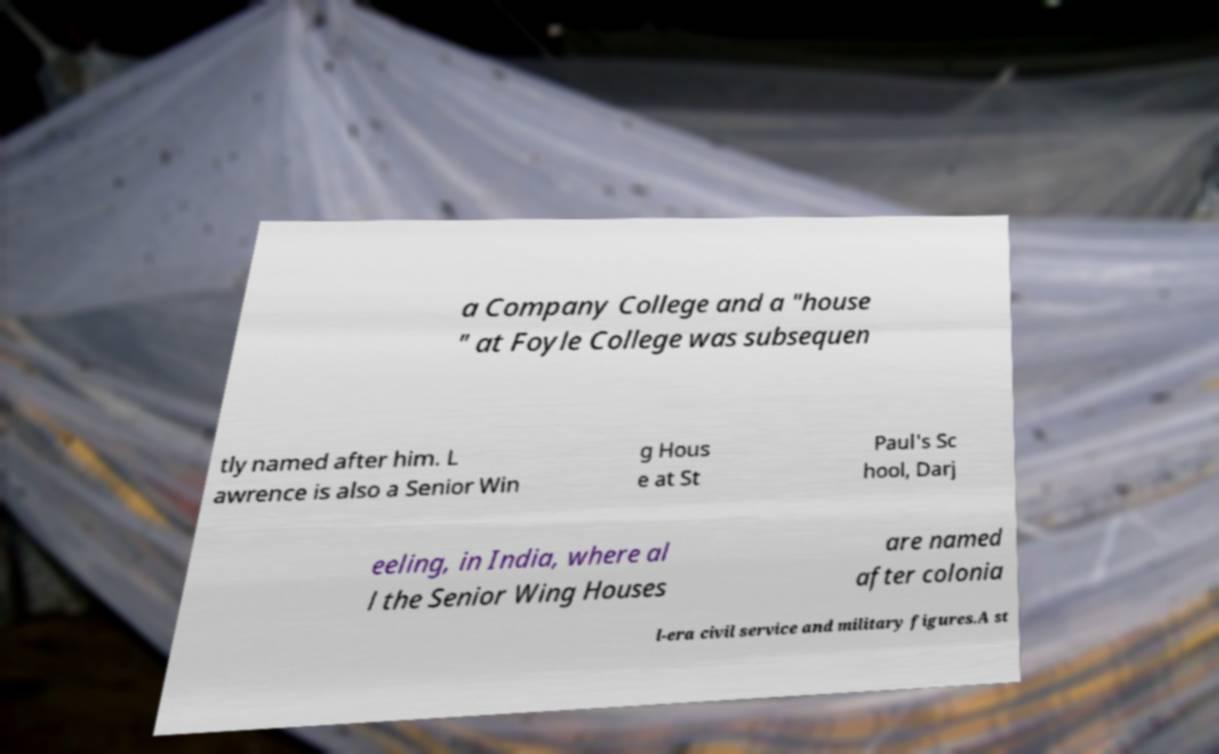Can you read and provide the text displayed in the image?This photo seems to have some interesting text. Can you extract and type it out for me? a Company College and a "house " at Foyle College was subsequen tly named after him. L awrence is also a Senior Win g Hous e at St Paul's Sc hool, Darj eeling, in India, where al l the Senior Wing Houses are named after colonia l-era civil service and military figures.A st 